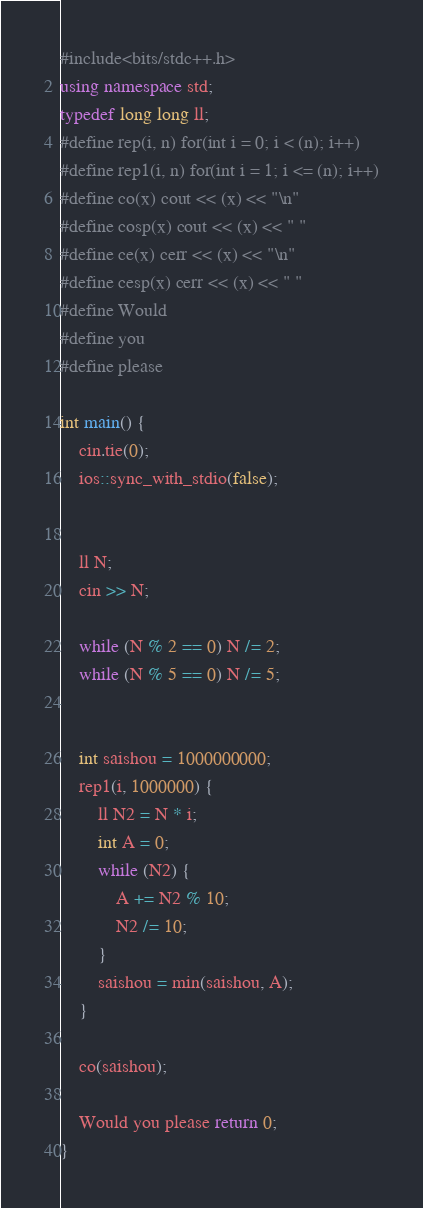Convert code to text. <code><loc_0><loc_0><loc_500><loc_500><_C++_>#include<bits/stdc++.h>
using namespace std;
typedef long long ll;
#define rep(i, n) for(int i = 0; i < (n); i++)
#define rep1(i, n) for(int i = 1; i <= (n); i++)
#define co(x) cout << (x) << "\n"
#define cosp(x) cout << (x) << " "
#define ce(x) cerr << (x) << "\n"
#define cesp(x) cerr << (x) << " "
#define Would
#define you
#define please

int main() {
	cin.tie(0);
	ios::sync_with_stdio(false);


	ll N;
	cin >> N;

	while (N % 2 == 0) N /= 2;
	while (N % 5 == 0) N /= 5;


	int saishou = 1000000000;
	rep1(i, 1000000) {
		ll N2 = N * i;
		int A = 0;
		while (N2) {
			A += N2 % 10;
			N2 /= 10;
		}
		saishou = min(saishou, A);
	}

	co(saishou);

	Would you please return 0;
}</code> 